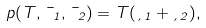<formula> <loc_0><loc_0><loc_500><loc_500>p ( T , \mu _ { 1 } , \mu _ { 2 } ) = T ( \xi _ { 1 } + \xi _ { 2 } ) ,</formula> 